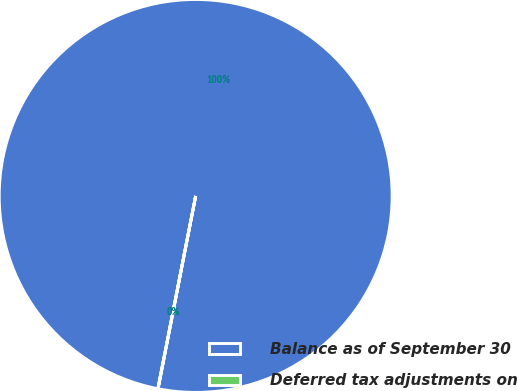Convert chart. <chart><loc_0><loc_0><loc_500><loc_500><pie_chart><fcel>Balance as of September 30<fcel>Deferred tax adjustments on<nl><fcel>99.98%<fcel>0.02%<nl></chart> 